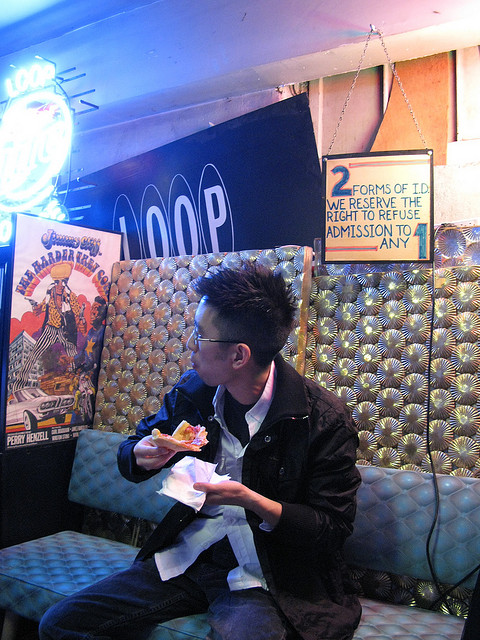Extract all visible text content from this image. FORMS OF WE REFUSE THE 2 1 ANY TO TO RIGHT RESERVE I.D. HEMTELL HARDER 